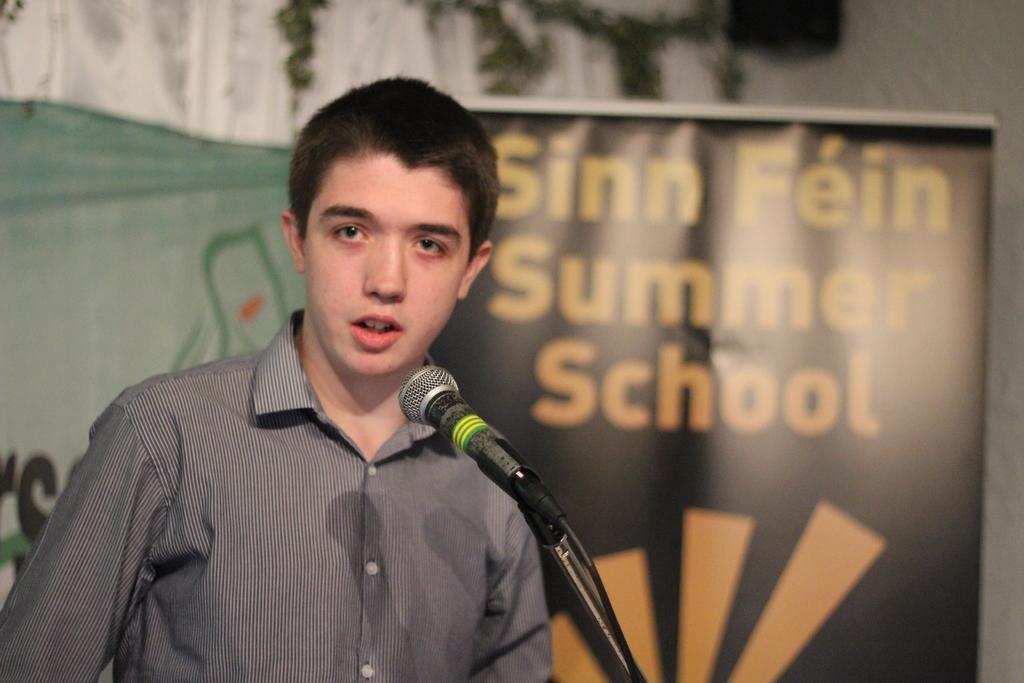In one or two sentences, can you explain what this image depicts? In this image we can see a person standing in front of the mic, also we can see the banners with some text on it, in the background, we can see the wall. 